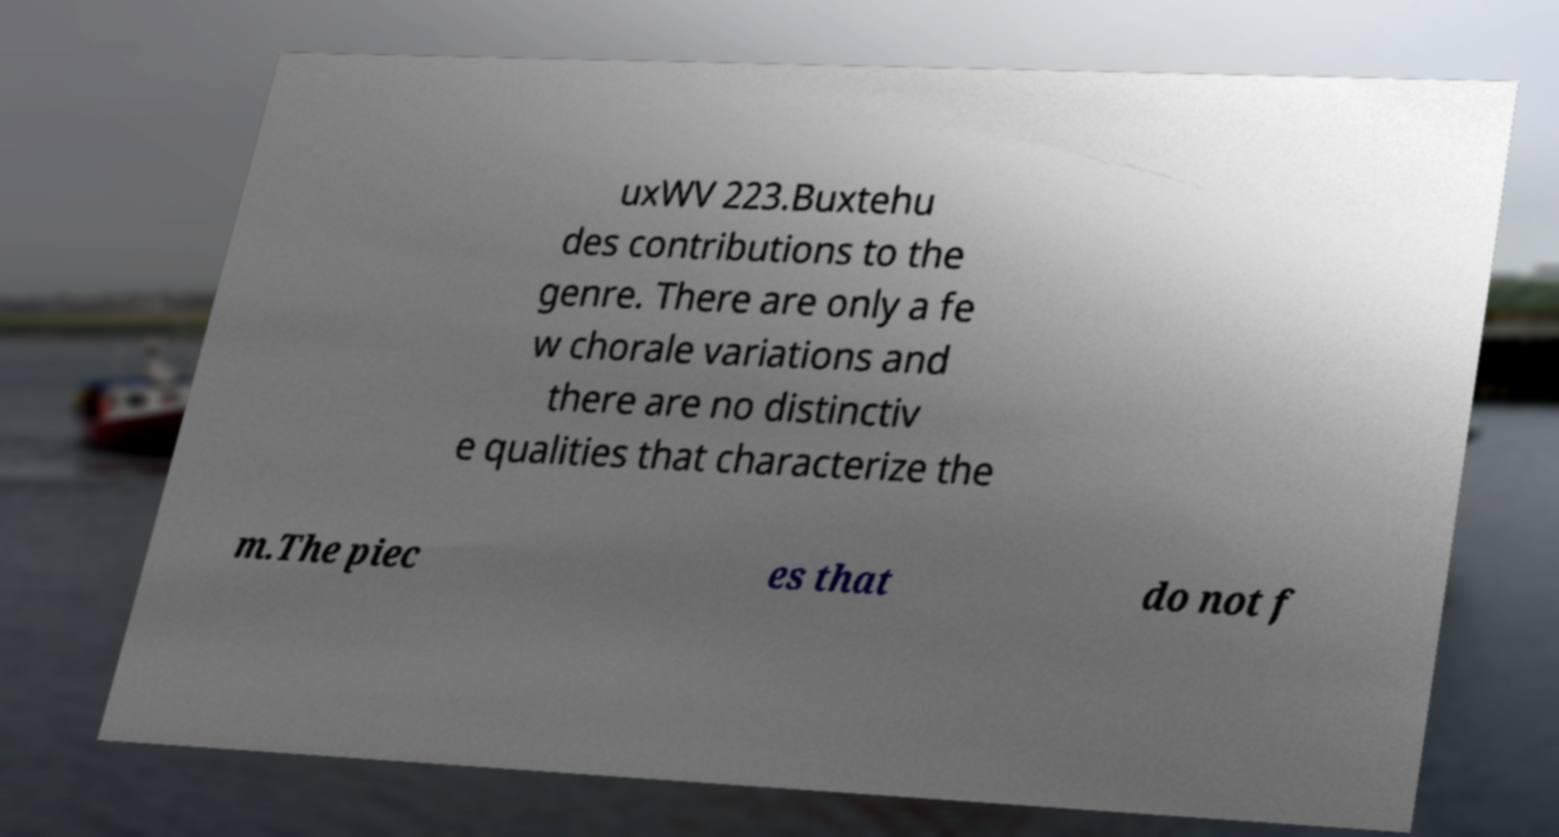Can you read and provide the text displayed in the image?This photo seems to have some interesting text. Can you extract and type it out for me? uxWV 223.Buxtehu des contributions to the genre. There are only a fe w chorale variations and there are no distinctiv e qualities that characterize the m.The piec es that do not f 